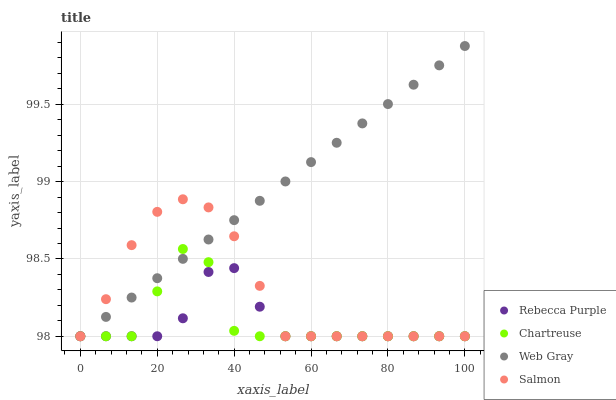Does Rebecca Purple have the minimum area under the curve?
Answer yes or no. Yes. Does Web Gray have the maximum area under the curve?
Answer yes or no. Yes. Does Salmon have the minimum area under the curve?
Answer yes or no. No. Does Salmon have the maximum area under the curve?
Answer yes or no. No. Is Web Gray the smoothest?
Answer yes or no. Yes. Is Chartreuse the roughest?
Answer yes or no. Yes. Is Salmon the smoothest?
Answer yes or no. No. Is Salmon the roughest?
Answer yes or no. No. Does Chartreuse have the lowest value?
Answer yes or no. Yes. Does Web Gray have the highest value?
Answer yes or no. Yes. Does Salmon have the highest value?
Answer yes or no. No. Does Salmon intersect Web Gray?
Answer yes or no. Yes. Is Salmon less than Web Gray?
Answer yes or no. No. Is Salmon greater than Web Gray?
Answer yes or no. No. 